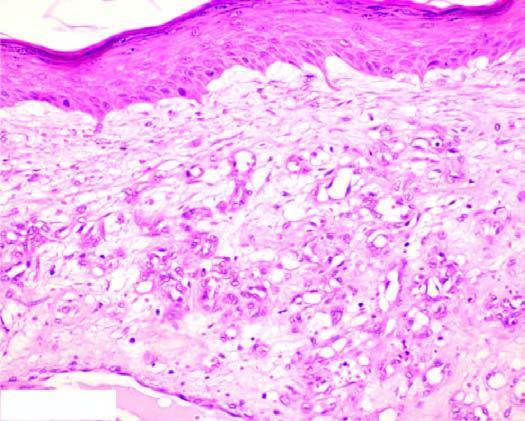does the interstitial vasculature consist of scant connective tissue?
Answer the question using a single word or phrase. No 